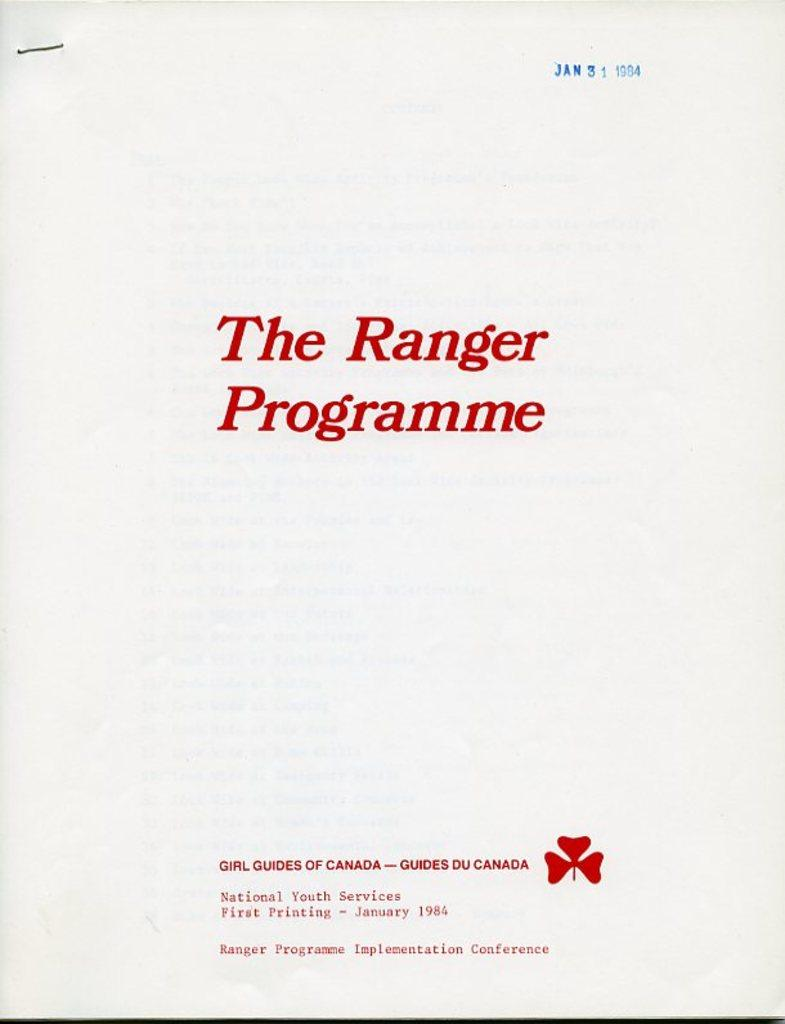Provide a one-sentence caption for the provided image. a booklet titled the ranger programme dated from January 31st 1984. 